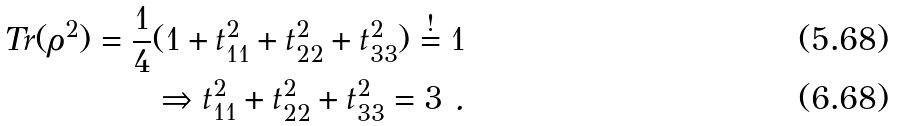<formula> <loc_0><loc_0><loc_500><loc_500>T r ( \rho ^ { 2 } ) = \frac { 1 } { 4 } ( 1 + t _ { 1 1 } ^ { 2 } + t _ { 2 2 } ^ { 2 } + t _ { 3 3 } ^ { 2 } ) \stackrel { ! } { = } 1 \\ \Rightarrow t _ { 1 1 } ^ { 2 } + t _ { 2 2 } ^ { 2 } + t _ { 3 3 } ^ { 2 } = 3 \ .</formula> 